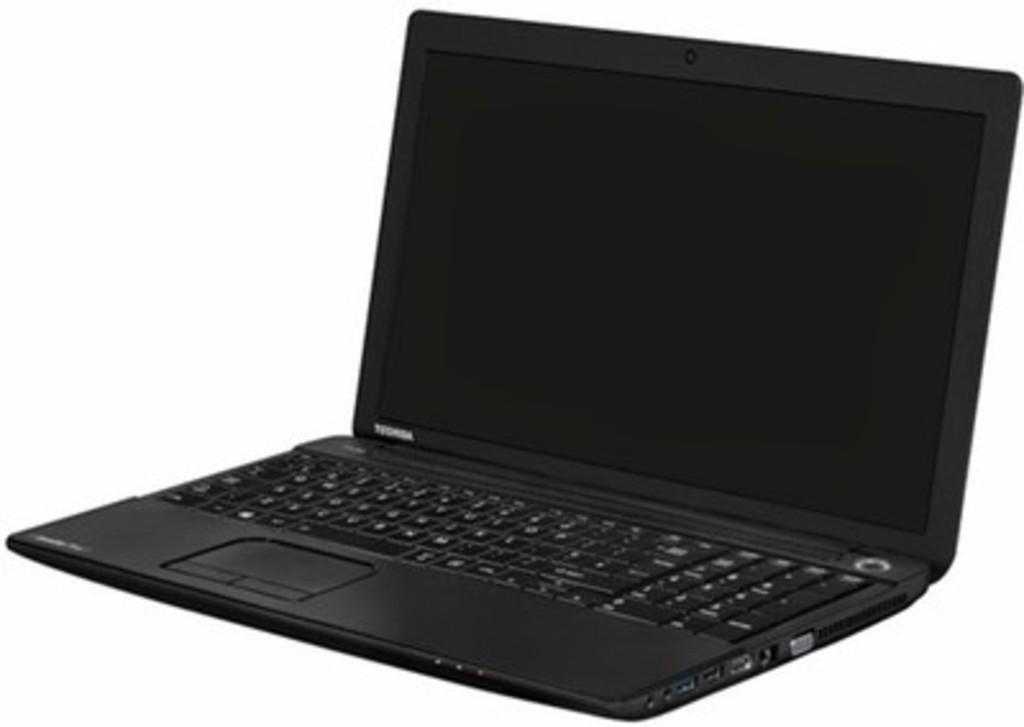<image>
Render a clear and concise summary of the photo. An open black laptop was manufactured by Toshiba. 